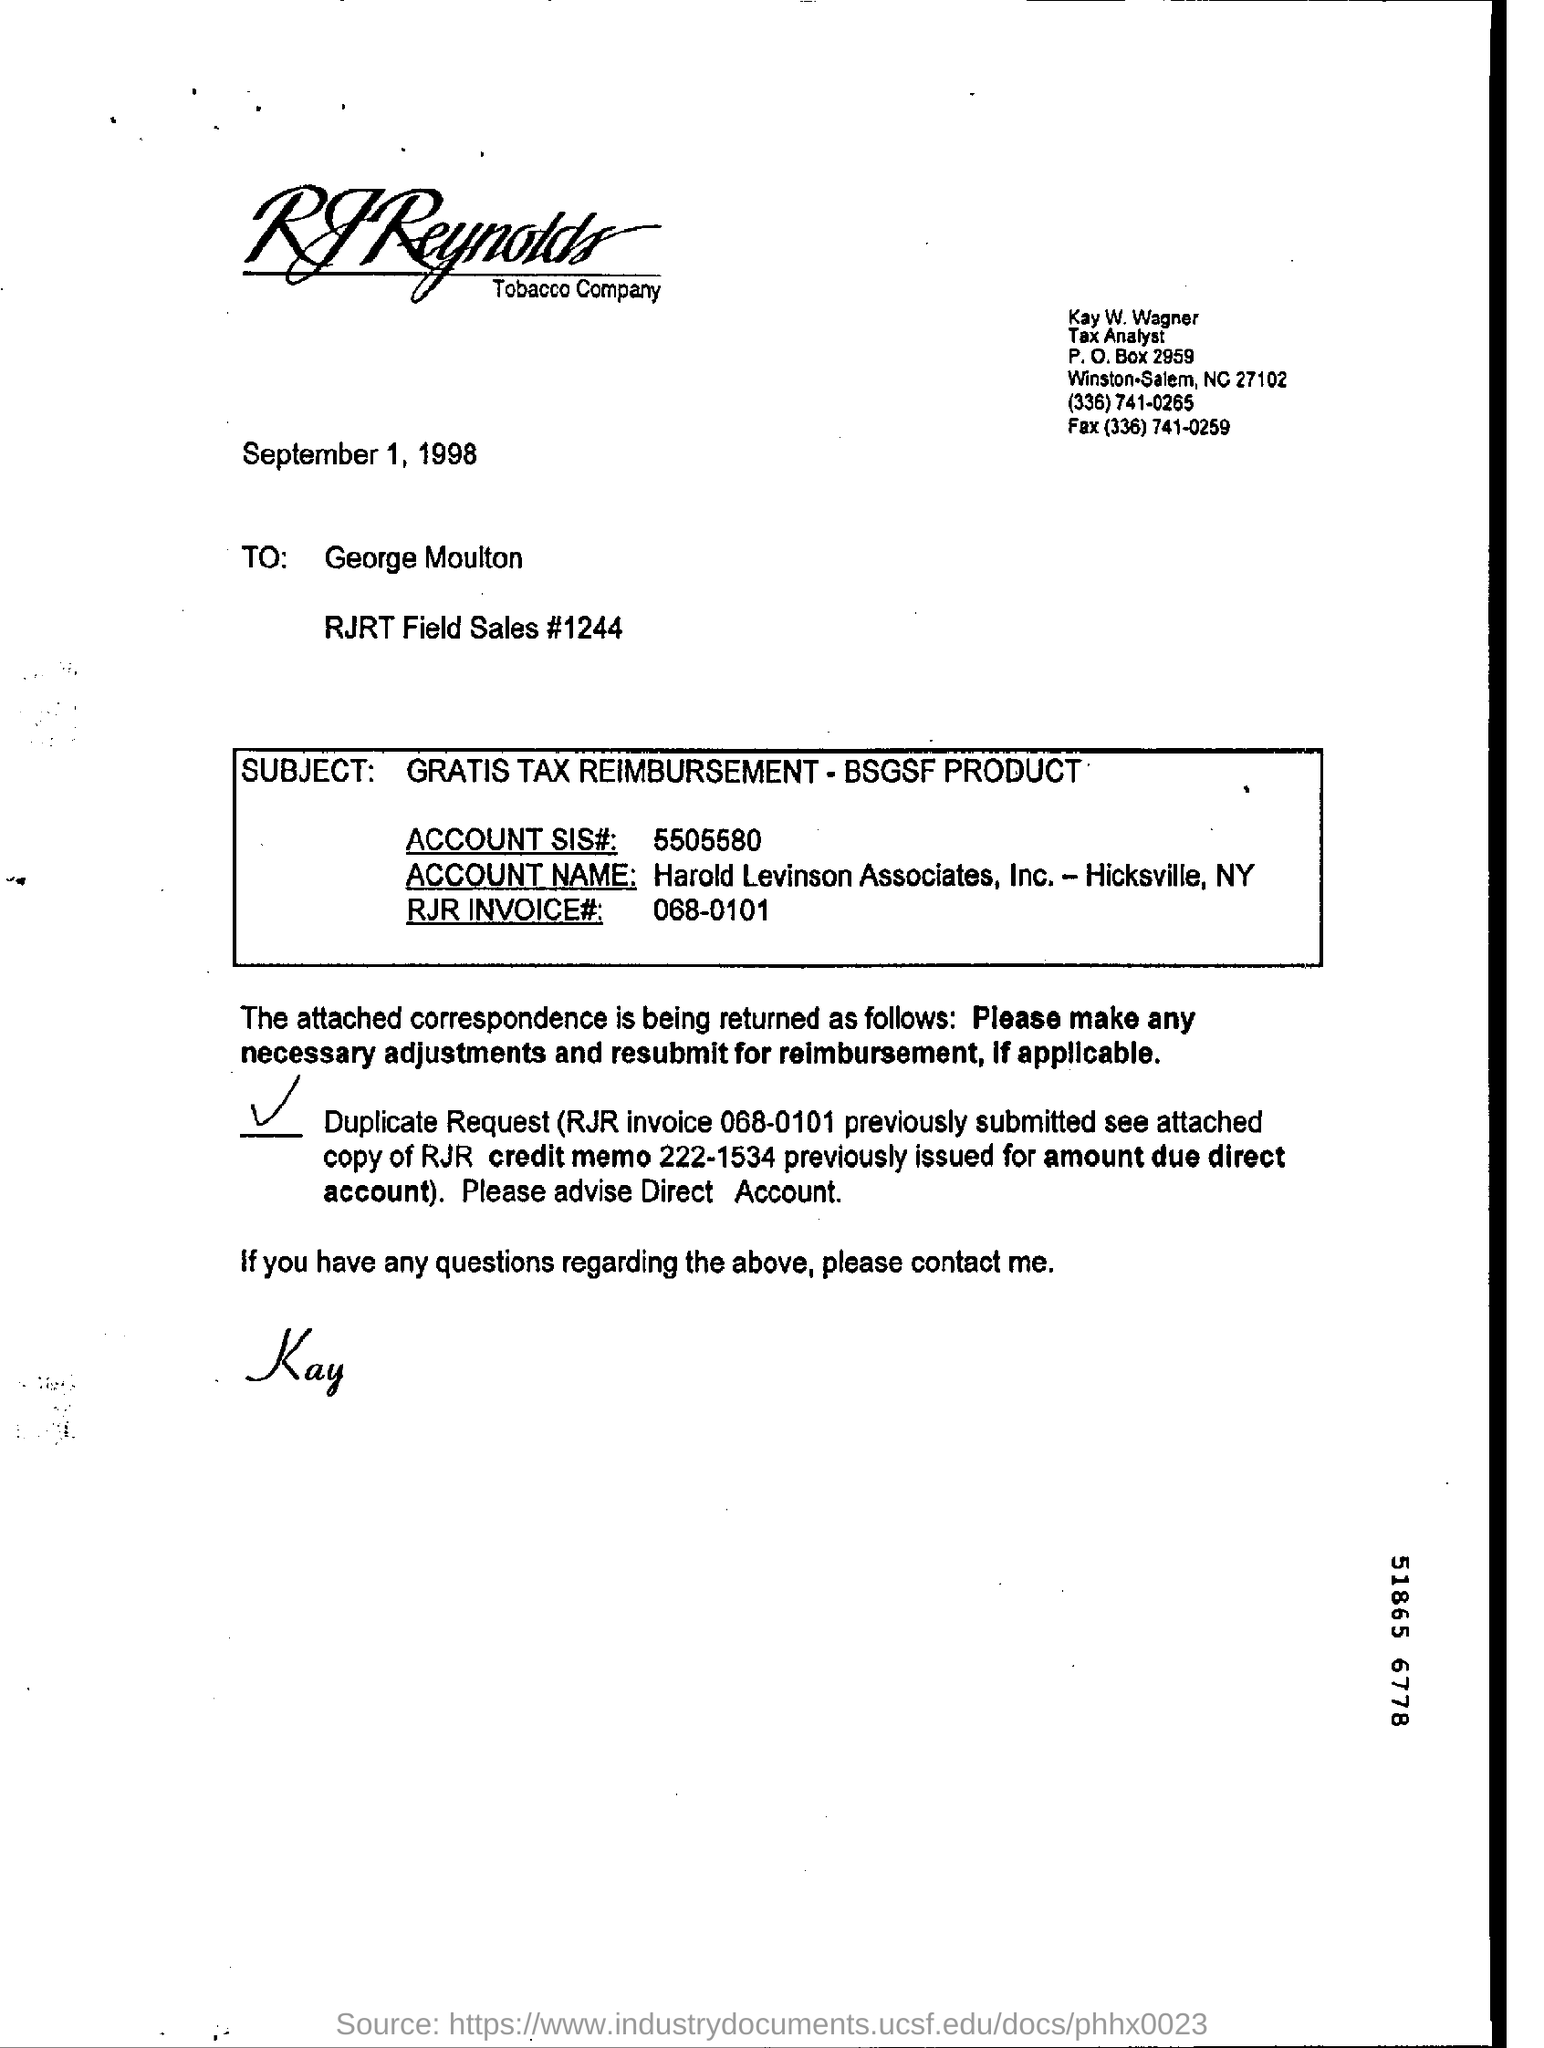Highlight a few significant elements in this photo. The RJR invoice number is 068-0101. The SIS account number is 5505580... The fax number in the letter is (336) 741-0259. The P.O box number in the letter is 2959. 